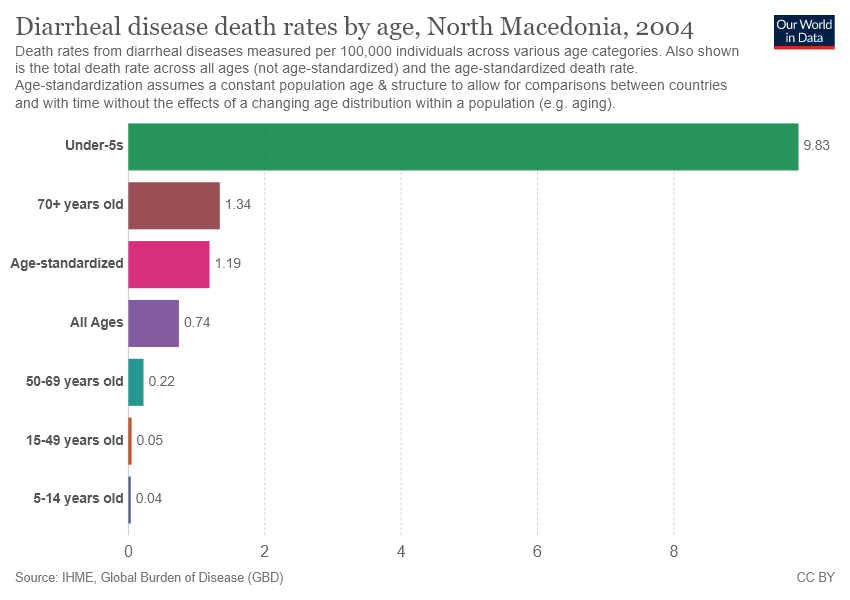Can you explain why the death rates are significantly higher in under-5s compared to other age groups? The higher death rates in under-5s could be due to a variety of factors including weaker immune systems in young children, higher susceptibility to dehydration caused by diarrheal diseases, and potentially less access to or awareness of preventive measures and treatments in this age group. What measures could potentially lower these rates? Improving access to clean water and sanitation, promoting and facilitating proper hygiene practices, and ensuring widespread availability of oral rehydration solutions and necessary medical care could significantly reduce diarrheal disease death rates among under-5s. 